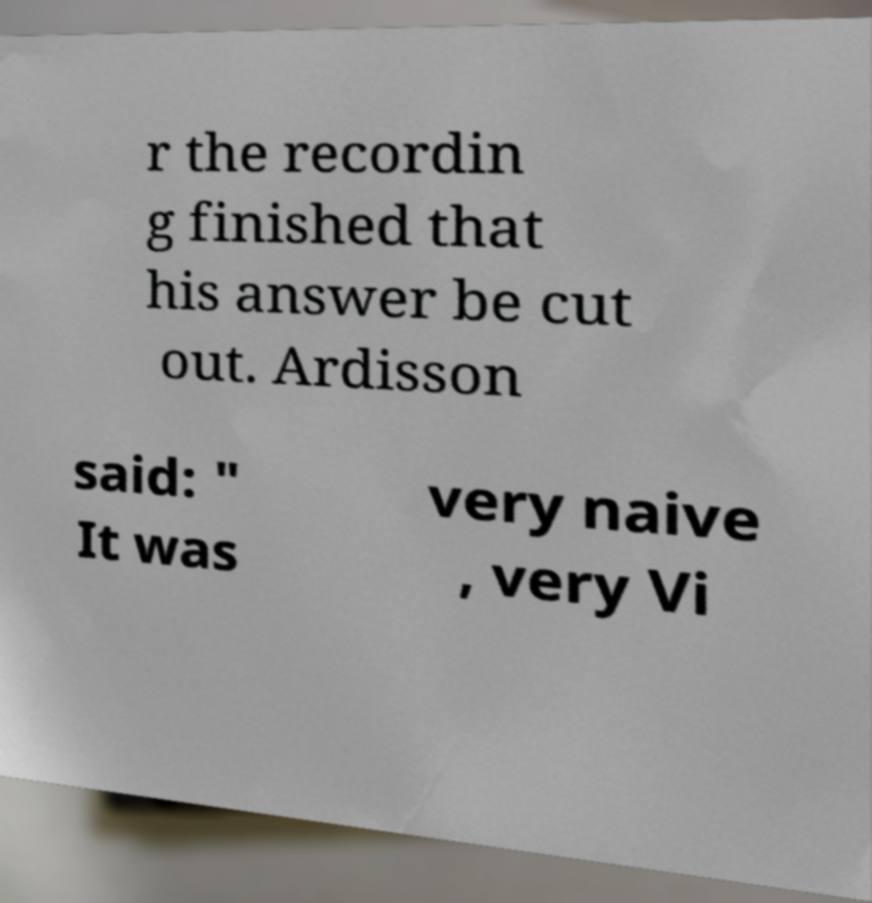For documentation purposes, I need the text within this image transcribed. Could you provide that? r the recordin g finished that his answer be cut out. Ardisson said: " It was very naive , very Vi 